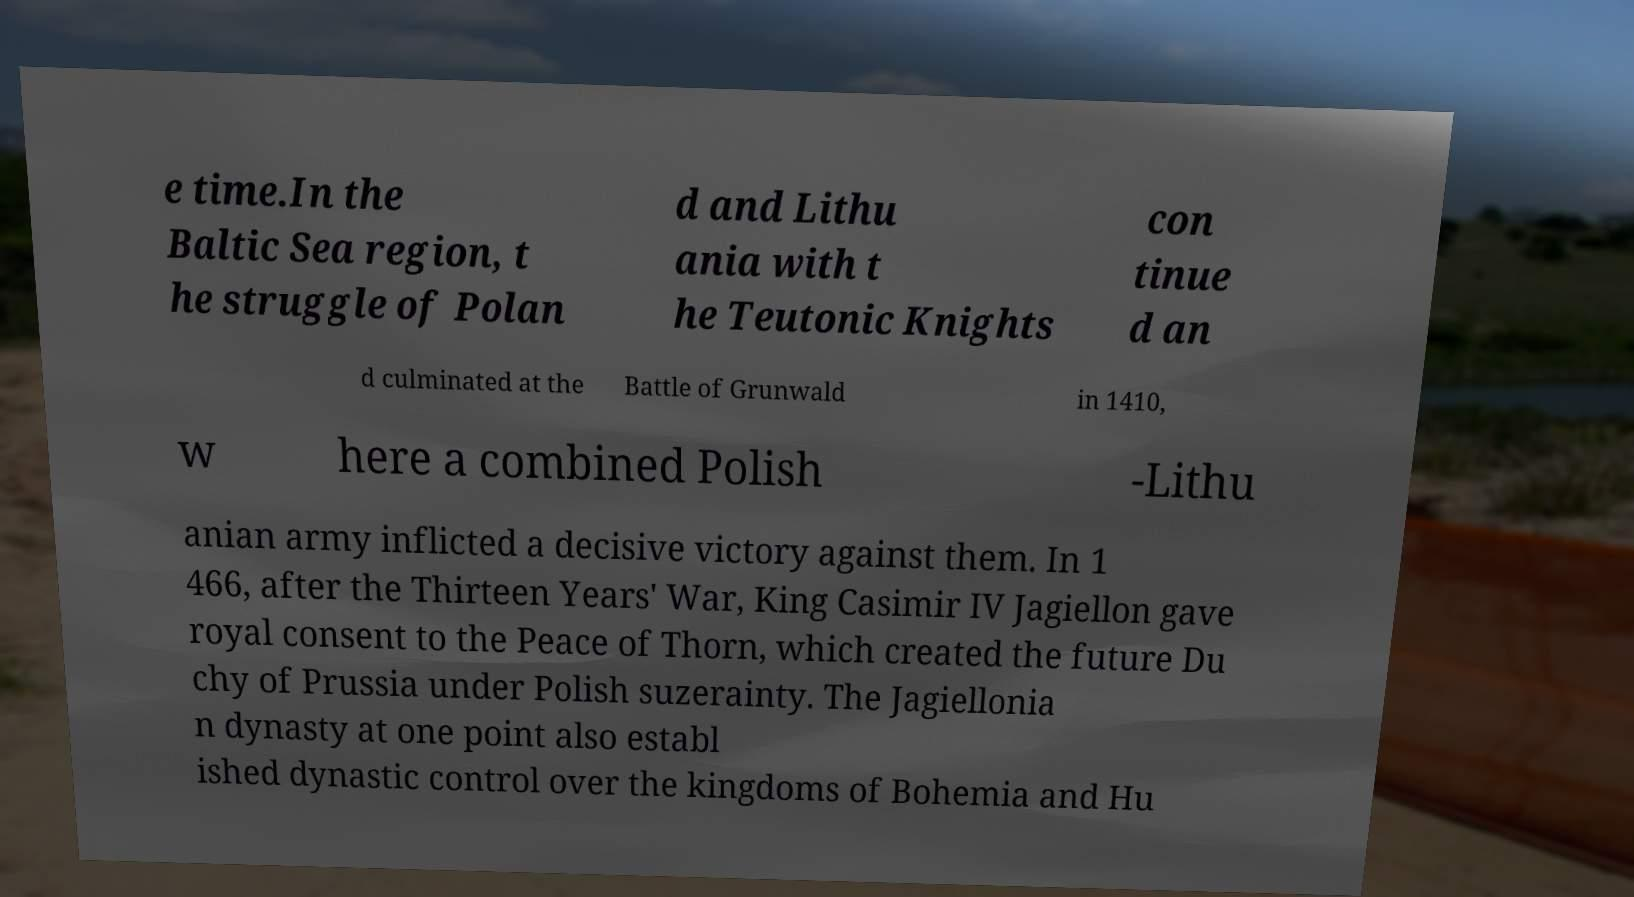Could you extract and type out the text from this image? e time.In the Baltic Sea region, t he struggle of Polan d and Lithu ania with t he Teutonic Knights con tinue d an d culminated at the Battle of Grunwald in 1410, w here a combined Polish -Lithu anian army inflicted a decisive victory against them. In 1 466, after the Thirteen Years' War, King Casimir IV Jagiellon gave royal consent to the Peace of Thorn, which created the future Du chy of Prussia under Polish suzerainty. The Jagiellonia n dynasty at one point also establ ished dynastic control over the kingdoms of Bohemia and Hu 